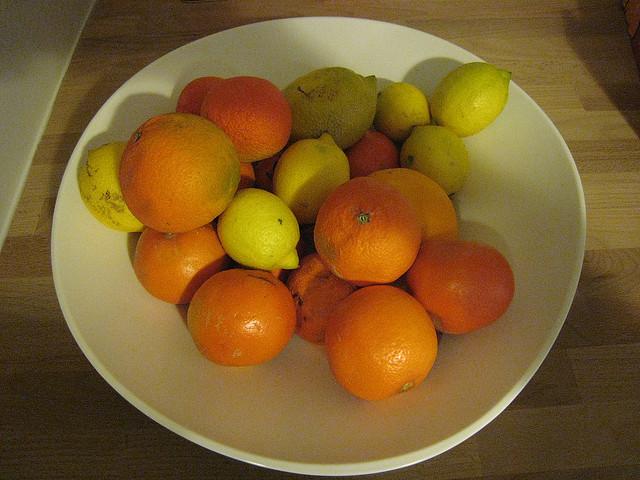How many different types of fruit are in the bowl?
Be succinct. 2. Are these ingredients for a homemade juice?
Be succinct. Yes. Is there a banana in the picture?
Be succinct. No. 